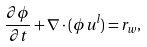Convert formula to latex. <formula><loc_0><loc_0><loc_500><loc_500>\frac { \partial \phi } { \partial t } + { \nabla } \cdot ( \phi { u } ^ { l } ) = r _ { w } ,</formula> 